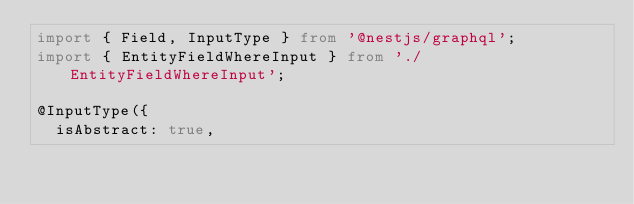Convert code to text. <code><loc_0><loc_0><loc_500><loc_500><_TypeScript_>import { Field, InputType } from '@nestjs/graphql';
import { EntityFieldWhereInput } from './EntityFieldWhereInput';

@InputType({
  isAbstract: true,</code> 